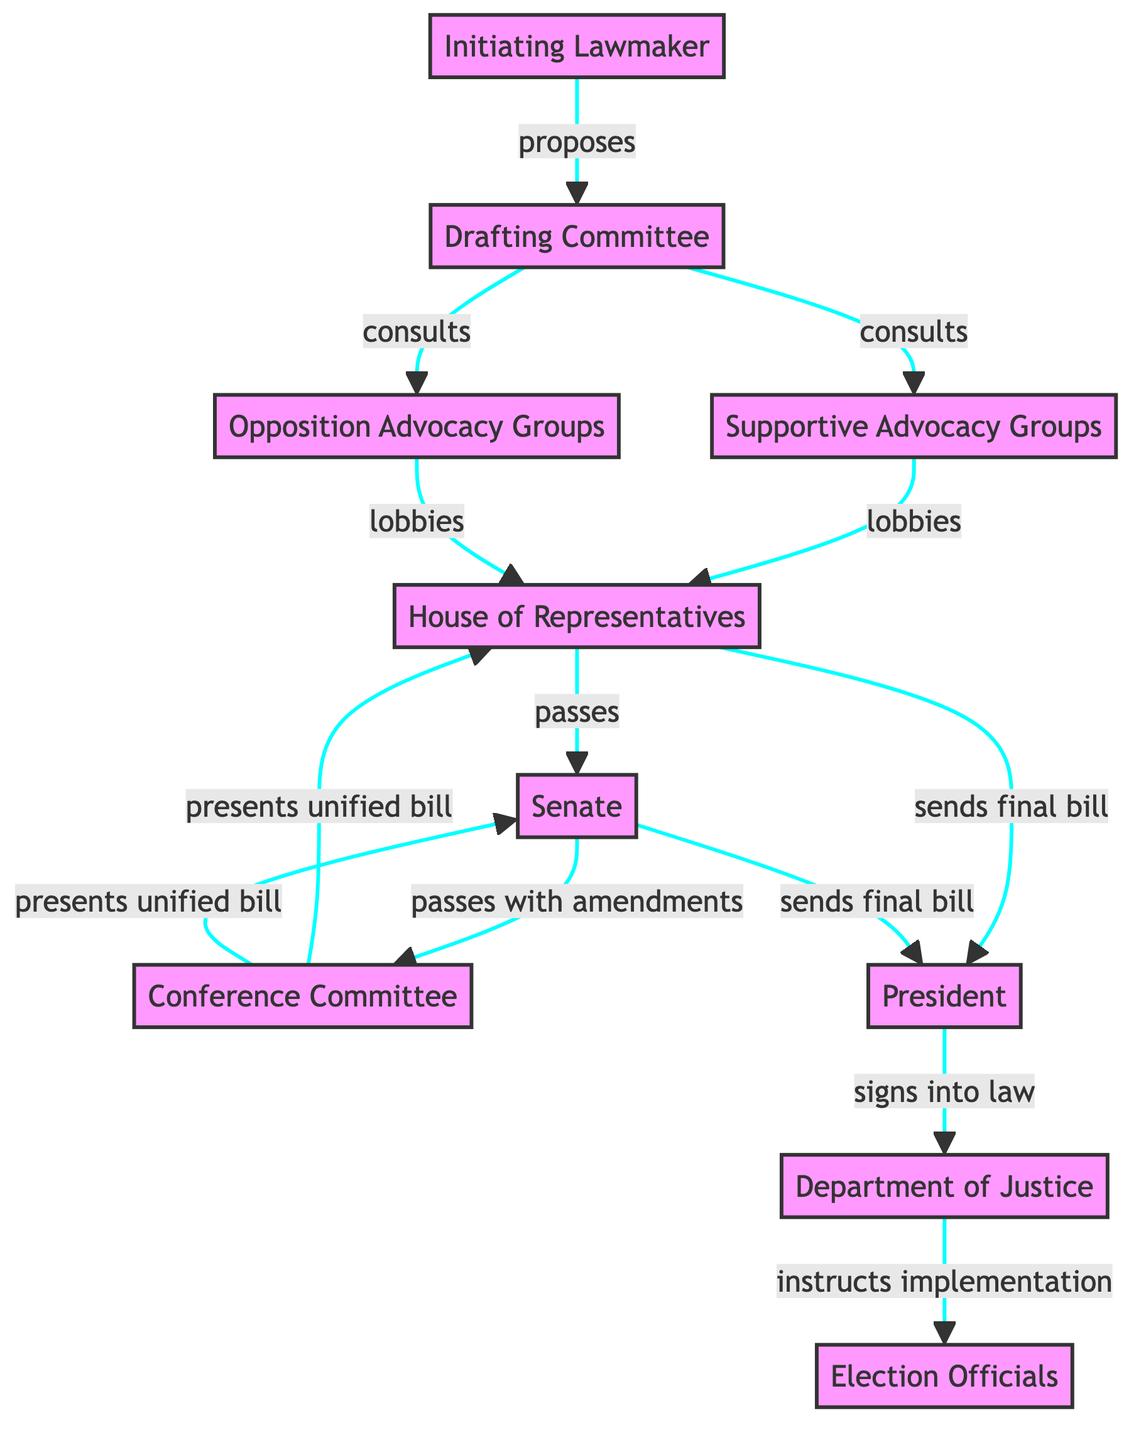What role does the Initiating Lawmaker play in the diagram? The Initiating Lawmaker is depicted as the entity that proposes the initial voting rights bill, serving as the foundation for the legislative process.
Answer: Proposes initial voting rights bill How many advocacy groups are shown in the diagram? The diagram shows two types of advocacy groups: Supportive Advocacy Groups and Opposition Advocacy Groups, resulting in a total of two distinct entities.
Answer: 2 What type of interaction exists between the Drafting Committee and the Supportive Advocacy Groups? The Drafting Committee consults with Supportive Advocacy Groups, indicating a collaborative process in drafting the legislation.
Answer: Consults Which entities are responsible for sending the final bill to the President? Both the House of Representatives and Senate send the final bill to the President, signifying the conclusion of the legislative process before the bill can potentially be enacted.
Answer: House of Representatives and Senate What happens after the President signs the bill into law? Once the President signs the bill into law, the Department of Justice is tasked with overseeing the implementation and ensuring compliance, demonstrating the continuation of the process beyond legislation.
Answer: Oversees implementation and ensures compliance Which committee resolves differences between the House and Senate versions of the bill? The Conference Committee is responsible for reconciling the differences between the House and Senate versions of the voting rights bill, thus playing a crucial role in the legislative process.
Answer: Conference Committee How do Opposition Advocacy Groups interact with the House of Representatives? Opposition Advocacy Groups lobby against the bill in the House of Representatives, trying to influence legislative decisions in their favor, reflecting the dynamics of advocacy in the legislative process.
Answer: Lobbies How does the Department of Justice relate to Election Officials after a bill is signed? The diagram shows the Department of Justice instructing Election Officials to implement changes, outlining their respective roles in the aftermath of the bill's enactment.
Answer: Instructs implementation What sequence follows after the House of Representatives passes the bill? After passing the bill, it is sent to the Senate, indicating a sequential process where each legislative chamber must review and vote on the proposed legislation in turn.
Answer: Sends final bill 